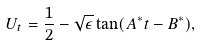Convert formula to latex. <formula><loc_0><loc_0><loc_500><loc_500>U _ { t } = { \frac { 1 } { 2 } } - \sqrt { \epsilon } \tan ( A ^ { * } t - B ^ { * } ) ,</formula> 